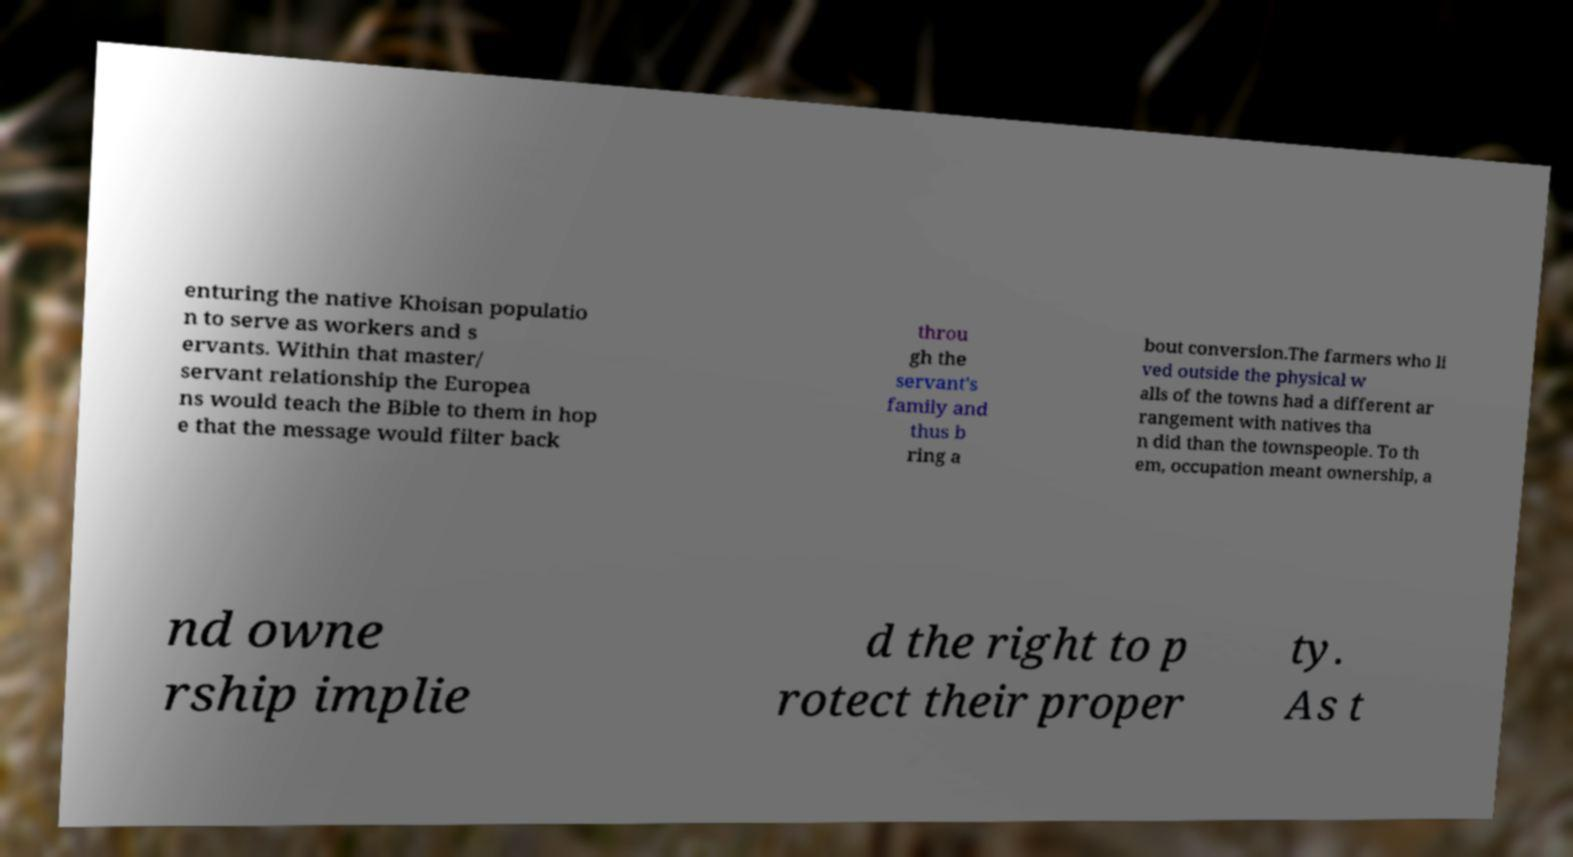There's text embedded in this image that I need extracted. Can you transcribe it verbatim? enturing the native Khoisan populatio n to serve as workers and s ervants. Within that master/ servant relationship the Europea ns would teach the Bible to them in hop e that the message would filter back throu gh the servant's family and thus b ring a bout conversion.The farmers who li ved outside the physical w alls of the towns had a different ar rangement with natives tha n did than the townspeople. To th em, occupation meant ownership, a nd owne rship implie d the right to p rotect their proper ty. As t 